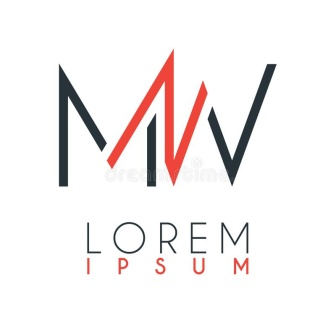Could you explain the potential symbolism behind the use of red and black in this logo? The use of red and black in the logo could serve multiple symbolic purposes. Black is often associated with elegance, strength, and sophistication, while red can symbolize passion, energy, and action. The contrast between the two could represent a balance of power and passion within the company's ethos. Visually, the stark contrast ensures the logo stands out and is memorable to onlookers. 